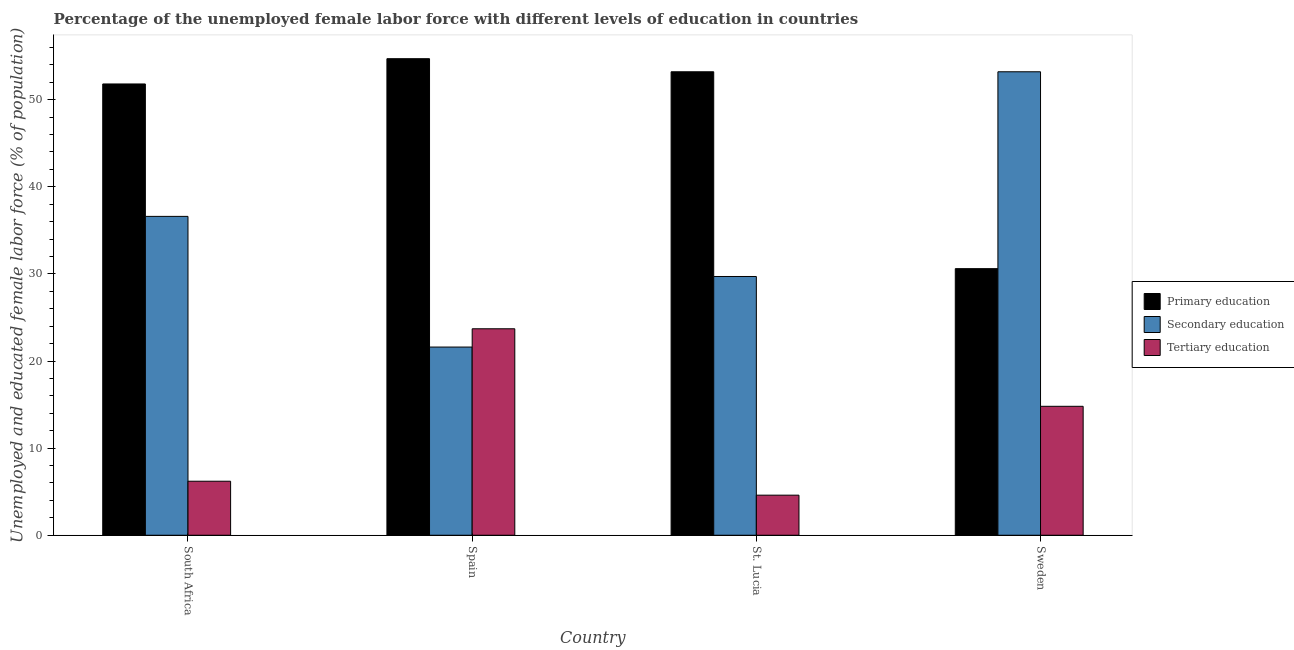Are the number of bars per tick equal to the number of legend labels?
Keep it short and to the point. Yes. How many bars are there on the 2nd tick from the right?
Provide a succinct answer. 3. What is the label of the 3rd group of bars from the left?
Provide a short and direct response. St. Lucia. In how many cases, is the number of bars for a given country not equal to the number of legend labels?
Give a very brief answer. 0. What is the percentage of female labor force who received primary education in South Africa?
Your answer should be compact. 51.8. Across all countries, what is the maximum percentage of female labor force who received tertiary education?
Ensure brevity in your answer.  23.7. Across all countries, what is the minimum percentage of female labor force who received tertiary education?
Give a very brief answer. 4.6. In which country was the percentage of female labor force who received secondary education maximum?
Give a very brief answer. Sweden. In which country was the percentage of female labor force who received tertiary education minimum?
Your answer should be compact. St. Lucia. What is the total percentage of female labor force who received primary education in the graph?
Ensure brevity in your answer.  190.3. What is the difference between the percentage of female labor force who received primary education in St. Lucia and that in Sweden?
Offer a terse response. 22.6. What is the difference between the percentage of female labor force who received tertiary education in Sweden and the percentage of female labor force who received primary education in St. Lucia?
Ensure brevity in your answer.  -38.4. What is the average percentage of female labor force who received tertiary education per country?
Keep it short and to the point. 12.33. What is the difference between the percentage of female labor force who received secondary education and percentage of female labor force who received tertiary education in South Africa?
Provide a succinct answer. 30.4. What is the ratio of the percentage of female labor force who received tertiary education in South Africa to that in St. Lucia?
Provide a succinct answer. 1.35. Is the difference between the percentage of female labor force who received tertiary education in Spain and Sweden greater than the difference between the percentage of female labor force who received secondary education in Spain and Sweden?
Give a very brief answer. Yes. What is the difference between the highest and the second highest percentage of female labor force who received primary education?
Offer a very short reply. 1.5. What is the difference between the highest and the lowest percentage of female labor force who received tertiary education?
Offer a very short reply. 19.1. What does the 3rd bar from the left in South Africa represents?
Keep it short and to the point. Tertiary education. What does the 1st bar from the right in Spain represents?
Keep it short and to the point. Tertiary education. Is it the case that in every country, the sum of the percentage of female labor force who received primary education and percentage of female labor force who received secondary education is greater than the percentage of female labor force who received tertiary education?
Keep it short and to the point. Yes. Are all the bars in the graph horizontal?
Your response must be concise. No. How many countries are there in the graph?
Your answer should be very brief. 4. How many legend labels are there?
Ensure brevity in your answer.  3. How are the legend labels stacked?
Provide a succinct answer. Vertical. What is the title of the graph?
Your answer should be very brief. Percentage of the unemployed female labor force with different levels of education in countries. What is the label or title of the Y-axis?
Your answer should be very brief. Unemployed and educated female labor force (% of population). What is the Unemployed and educated female labor force (% of population) of Primary education in South Africa?
Your answer should be compact. 51.8. What is the Unemployed and educated female labor force (% of population) of Secondary education in South Africa?
Your response must be concise. 36.6. What is the Unemployed and educated female labor force (% of population) in Tertiary education in South Africa?
Provide a succinct answer. 6.2. What is the Unemployed and educated female labor force (% of population) in Primary education in Spain?
Keep it short and to the point. 54.7. What is the Unemployed and educated female labor force (% of population) in Secondary education in Spain?
Provide a short and direct response. 21.6. What is the Unemployed and educated female labor force (% of population) of Tertiary education in Spain?
Ensure brevity in your answer.  23.7. What is the Unemployed and educated female labor force (% of population) of Primary education in St. Lucia?
Your response must be concise. 53.2. What is the Unemployed and educated female labor force (% of population) in Secondary education in St. Lucia?
Offer a terse response. 29.7. What is the Unemployed and educated female labor force (% of population) in Tertiary education in St. Lucia?
Keep it short and to the point. 4.6. What is the Unemployed and educated female labor force (% of population) in Primary education in Sweden?
Offer a terse response. 30.6. What is the Unemployed and educated female labor force (% of population) in Secondary education in Sweden?
Your response must be concise. 53.2. What is the Unemployed and educated female labor force (% of population) of Tertiary education in Sweden?
Your answer should be compact. 14.8. Across all countries, what is the maximum Unemployed and educated female labor force (% of population) of Primary education?
Make the answer very short. 54.7. Across all countries, what is the maximum Unemployed and educated female labor force (% of population) in Secondary education?
Offer a terse response. 53.2. Across all countries, what is the maximum Unemployed and educated female labor force (% of population) in Tertiary education?
Provide a short and direct response. 23.7. Across all countries, what is the minimum Unemployed and educated female labor force (% of population) of Primary education?
Ensure brevity in your answer.  30.6. Across all countries, what is the minimum Unemployed and educated female labor force (% of population) in Secondary education?
Provide a short and direct response. 21.6. Across all countries, what is the minimum Unemployed and educated female labor force (% of population) in Tertiary education?
Provide a short and direct response. 4.6. What is the total Unemployed and educated female labor force (% of population) in Primary education in the graph?
Your response must be concise. 190.3. What is the total Unemployed and educated female labor force (% of population) in Secondary education in the graph?
Give a very brief answer. 141.1. What is the total Unemployed and educated female labor force (% of population) of Tertiary education in the graph?
Ensure brevity in your answer.  49.3. What is the difference between the Unemployed and educated female labor force (% of population) of Primary education in South Africa and that in Spain?
Keep it short and to the point. -2.9. What is the difference between the Unemployed and educated female labor force (% of population) in Tertiary education in South Africa and that in Spain?
Your answer should be very brief. -17.5. What is the difference between the Unemployed and educated female labor force (% of population) in Primary education in South Africa and that in St. Lucia?
Provide a succinct answer. -1.4. What is the difference between the Unemployed and educated female labor force (% of population) in Primary education in South Africa and that in Sweden?
Provide a succinct answer. 21.2. What is the difference between the Unemployed and educated female labor force (% of population) of Secondary education in South Africa and that in Sweden?
Keep it short and to the point. -16.6. What is the difference between the Unemployed and educated female labor force (% of population) in Tertiary education in South Africa and that in Sweden?
Provide a succinct answer. -8.6. What is the difference between the Unemployed and educated female labor force (% of population) of Primary education in Spain and that in St. Lucia?
Provide a short and direct response. 1.5. What is the difference between the Unemployed and educated female labor force (% of population) of Secondary education in Spain and that in St. Lucia?
Keep it short and to the point. -8.1. What is the difference between the Unemployed and educated female labor force (% of population) in Primary education in Spain and that in Sweden?
Make the answer very short. 24.1. What is the difference between the Unemployed and educated female labor force (% of population) in Secondary education in Spain and that in Sweden?
Your response must be concise. -31.6. What is the difference between the Unemployed and educated female labor force (% of population) of Tertiary education in Spain and that in Sweden?
Make the answer very short. 8.9. What is the difference between the Unemployed and educated female labor force (% of population) in Primary education in St. Lucia and that in Sweden?
Your response must be concise. 22.6. What is the difference between the Unemployed and educated female labor force (% of population) in Secondary education in St. Lucia and that in Sweden?
Your answer should be very brief. -23.5. What is the difference between the Unemployed and educated female labor force (% of population) in Tertiary education in St. Lucia and that in Sweden?
Offer a very short reply. -10.2. What is the difference between the Unemployed and educated female labor force (% of population) of Primary education in South Africa and the Unemployed and educated female labor force (% of population) of Secondary education in Spain?
Ensure brevity in your answer.  30.2. What is the difference between the Unemployed and educated female labor force (% of population) of Primary education in South Africa and the Unemployed and educated female labor force (% of population) of Tertiary education in Spain?
Offer a terse response. 28.1. What is the difference between the Unemployed and educated female labor force (% of population) in Secondary education in South Africa and the Unemployed and educated female labor force (% of population) in Tertiary education in Spain?
Offer a very short reply. 12.9. What is the difference between the Unemployed and educated female labor force (% of population) in Primary education in South Africa and the Unemployed and educated female labor force (% of population) in Secondary education in St. Lucia?
Keep it short and to the point. 22.1. What is the difference between the Unemployed and educated female labor force (% of population) of Primary education in South Africa and the Unemployed and educated female labor force (% of population) of Tertiary education in St. Lucia?
Make the answer very short. 47.2. What is the difference between the Unemployed and educated female labor force (% of population) in Secondary education in South Africa and the Unemployed and educated female labor force (% of population) in Tertiary education in St. Lucia?
Offer a very short reply. 32. What is the difference between the Unemployed and educated female labor force (% of population) in Primary education in South Africa and the Unemployed and educated female labor force (% of population) in Secondary education in Sweden?
Ensure brevity in your answer.  -1.4. What is the difference between the Unemployed and educated female labor force (% of population) in Secondary education in South Africa and the Unemployed and educated female labor force (% of population) in Tertiary education in Sweden?
Give a very brief answer. 21.8. What is the difference between the Unemployed and educated female labor force (% of population) of Primary education in Spain and the Unemployed and educated female labor force (% of population) of Secondary education in St. Lucia?
Make the answer very short. 25. What is the difference between the Unemployed and educated female labor force (% of population) of Primary education in Spain and the Unemployed and educated female labor force (% of population) of Tertiary education in St. Lucia?
Provide a short and direct response. 50.1. What is the difference between the Unemployed and educated female labor force (% of population) of Secondary education in Spain and the Unemployed and educated female labor force (% of population) of Tertiary education in St. Lucia?
Your answer should be compact. 17. What is the difference between the Unemployed and educated female labor force (% of population) of Primary education in Spain and the Unemployed and educated female labor force (% of population) of Tertiary education in Sweden?
Your response must be concise. 39.9. What is the difference between the Unemployed and educated female labor force (% of population) in Primary education in St. Lucia and the Unemployed and educated female labor force (% of population) in Tertiary education in Sweden?
Provide a short and direct response. 38.4. What is the average Unemployed and educated female labor force (% of population) of Primary education per country?
Offer a very short reply. 47.58. What is the average Unemployed and educated female labor force (% of population) in Secondary education per country?
Provide a short and direct response. 35.27. What is the average Unemployed and educated female labor force (% of population) in Tertiary education per country?
Your response must be concise. 12.32. What is the difference between the Unemployed and educated female labor force (% of population) in Primary education and Unemployed and educated female labor force (% of population) in Tertiary education in South Africa?
Provide a short and direct response. 45.6. What is the difference between the Unemployed and educated female labor force (% of population) in Secondary education and Unemployed and educated female labor force (% of population) in Tertiary education in South Africa?
Make the answer very short. 30.4. What is the difference between the Unemployed and educated female labor force (% of population) of Primary education and Unemployed and educated female labor force (% of population) of Secondary education in Spain?
Offer a terse response. 33.1. What is the difference between the Unemployed and educated female labor force (% of population) in Secondary education and Unemployed and educated female labor force (% of population) in Tertiary education in Spain?
Offer a terse response. -2.1. What is the difference between the Unemployed and educated female labor force (% of population) in Primary education and Unemployed and educated female labor force (% of population) in Tertiary education in St. Lucia?
Provide a succinct answer. 48.6. What is the difference between the Unemployed and educated female labor force (% of population) in Secondary education and Unemployed and educated female labor force (% of population) in Tertiary education in St. Lucia?
Your answer should be compact. 25.1. What is the difference between the Unemployed and educated female labor force (% of population) of Primary education and Unemployed and educated female labor force (% of population) of Secondary education in Sweden?
Your answer should be very brief. -22.6. What is the difference between the Unemployed and educated female labor force (% of population) of Secondary education and Unemployed and educated female labor force (% of population) of Tertiary education in Sweden?
Your answer should be compact. 38.4. What is the ratio of the Unemployed and educated female labor force (% of population) in Primary education in South Africa to that in Spain?
Your answer should be very brief. 0.95. What is the ratio of the Unemployed and educated female labor force (% of population) of Secondary education in South Africa to that in Spain?
Give a very brief answer. 1.69. What is the ratio of the Unemployed and educated female labor force (% of population) of Tertiary education in South Africa to that in Spain?
Ensure brevity in your answer.  0.26. What is the ratio of the Unemployed and educated female labor force (% of population) in Primary education in South Africa to that in St. Lucia?
Ensure brevity in your answer.  0.97. What is the ratio of the Unemployed and educated female labor force (% of population) of Secondary education in South Africa to that in St. Lucia?
Keep it short and to the point. 1.23. What is the ratio of the Unemployed and educated female labor force (% of population) in Tertiary education in South Africa to that in St. Lucia?
Your response must be concise. 1.35. What is the ratio of the Unemployed and educated female labor force (% of population) in Primary education in South Africa to that in Sweden?
Give a very brief answer. 1.69. What is the ratio of the Unemployed and educated female labor force (% of population) of Secondary education in South Africa to that in Sweden?
Give a very brief answer. 0.69. What is the ratio of the Unemployed and educated female labor force (% of population) in Tertiary education in South Africa to that in Sweden?
Provide a succinct answer. 0.42. What is the ratio of the Unemployed and educated female labor force (% of population) of Primary education in Spain to that in St. Lucia?
Offer a very short reply. 1.03. What is the ratio of the Unemployed and educated female labor force (% of population) of Secondary education in Spain to that in St. Lucia?
Your answer should be very brief. 0.73. What is the ratio of the Unemployed and educated female labor force (% of population) of Tertiary education in Spain to that in St. Lucia?
Give a very brief answer. 5.15. What is the ratio of the Unemployed and educated female labor force (% of population) of Primary education in Spain to that in Sweden?
Make the answer very short. 1.79. What is the ratio of the Unemployed and educated female labor force (% of population) in Secondary education in Spain to that in Sweden?
Your answer should be compact. 0.41. What is the ratio of the Unemployed and educated female labor force (% of population) of Tertiary education in Spain to that in Sweden?
Your response must be concise. 1.6. What is the ratio of the Unemployed and educated female labor force (% of population) in Primary education in St. Lucia to that in Sweden?
Give a very brief answer. 1.74. What is the ratio of the Unemployed and educated female labor force (% of population) of Secondary education in St. Lucia to that in Sweden?
Offer a very short reply. 0.56. What is the ratio of the Unemployed and educated female labor force (% of population) in Tertiary education in St. Lucia to that in Sweden?
Ensure brevity in your answer.  0.31. What is the difference between the highest and the second highest Unemployed and educated female labor force (% of population) in Primary education?
Ensure brevity in your answer.  1.5. What is the difference between the highest and the second highest Unemployed and educated female labor force (% of population) in Tertiary education?
Your answer should be compact. 8.9. What is the difference between the highest and the lowest Unemployed and educated female labor force (% of population) of Primary education?
Offer a very short reply. 24.1. What is the difference between the highest and the lowest Unemployed and educated female labor force (% of population) in Secondary education?
Give a very brief answer. 31.6. What is the difference between the highest and the lowest Unemployed and educated female labor force (% of population) in Tertiary education?
Ensure brevity in your answer.  19.1. 